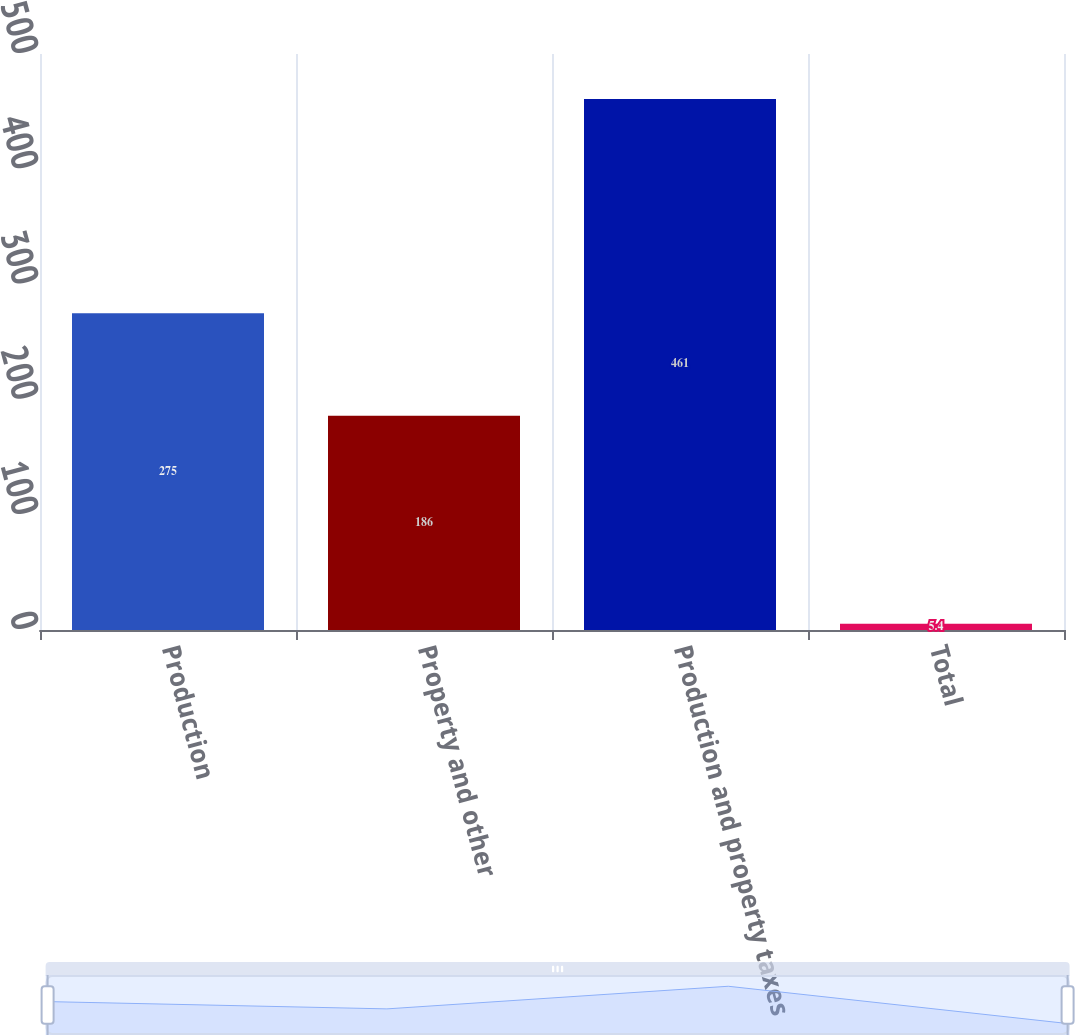Convert chart to OTSL. <chart><loc_0><loc_0><loc_500><loc_500><bar_chart><fcel>Production<fcel>Property and other<fcel>Production and property taxes<fcel>Total<nl><fcel>275<fcel>186<fcel>461<fcel>5.4<nl></chart> 